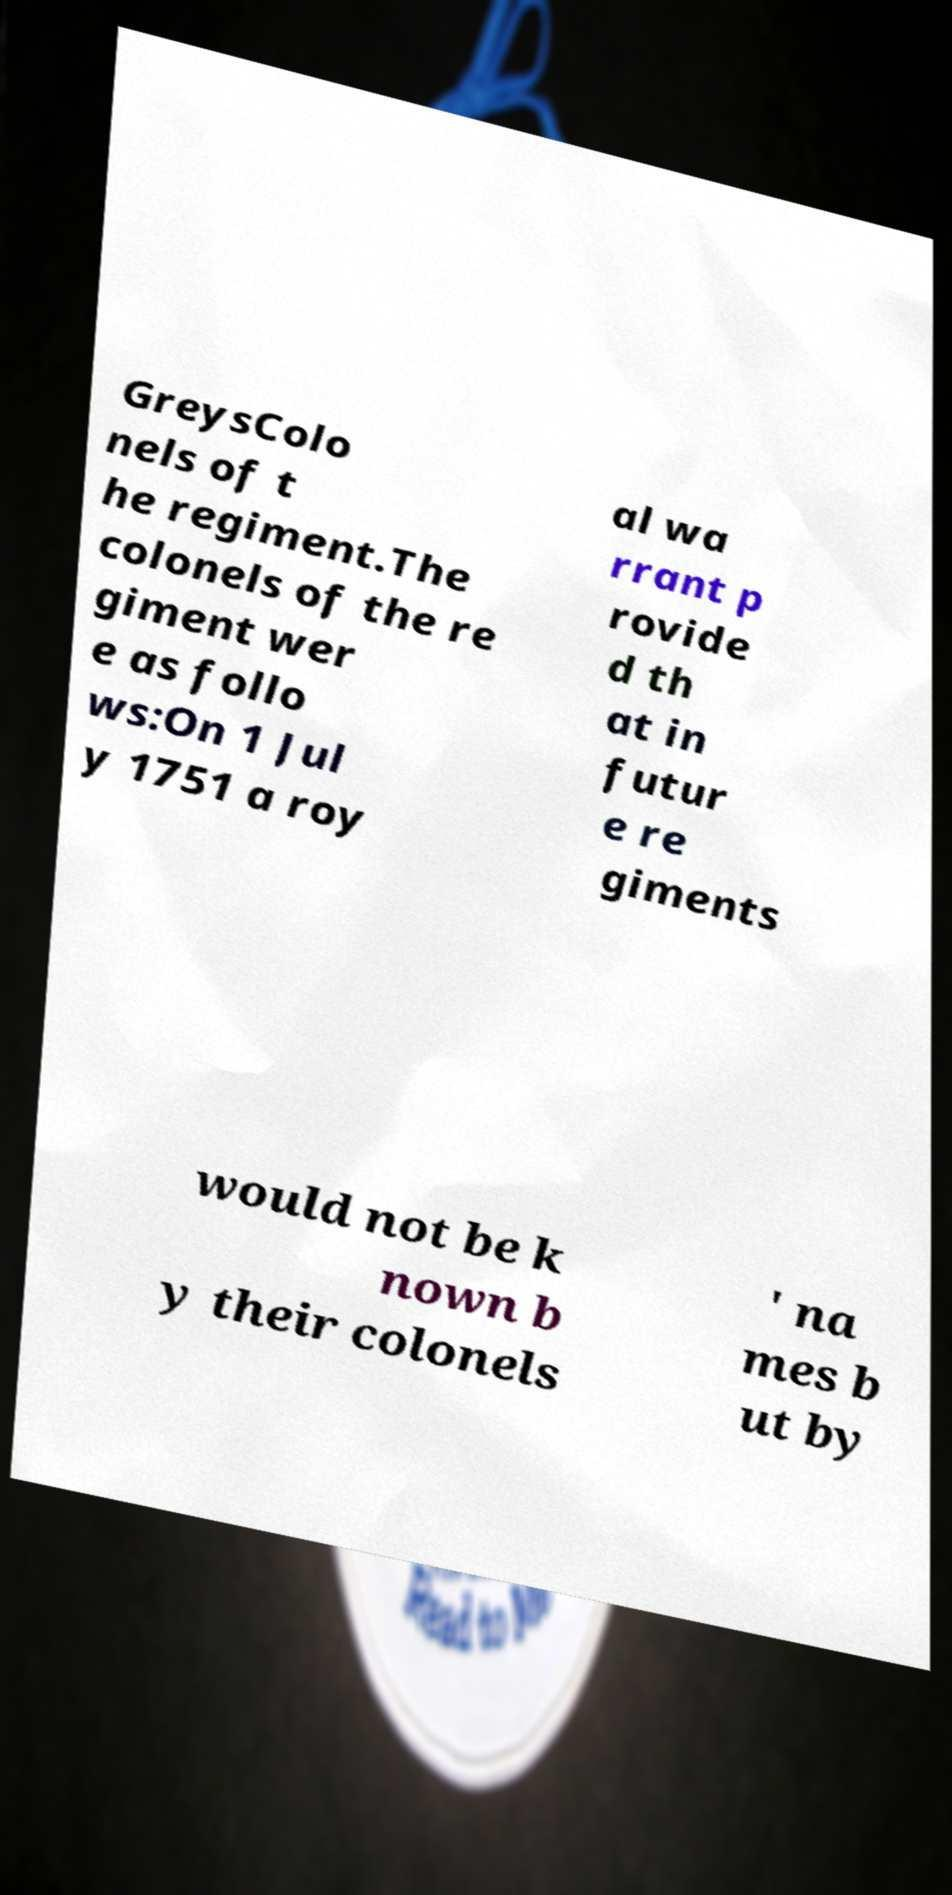Please identify and transcribe the text found in this image. GreysColo nels of t he regiment.The colonels of the re giment wer e as follo ws:On 1 Jul y 1751 a roy al wa rrant p rovide d th at in futur e re giments would not be k nown b y their colonels ' na mes b ut by 